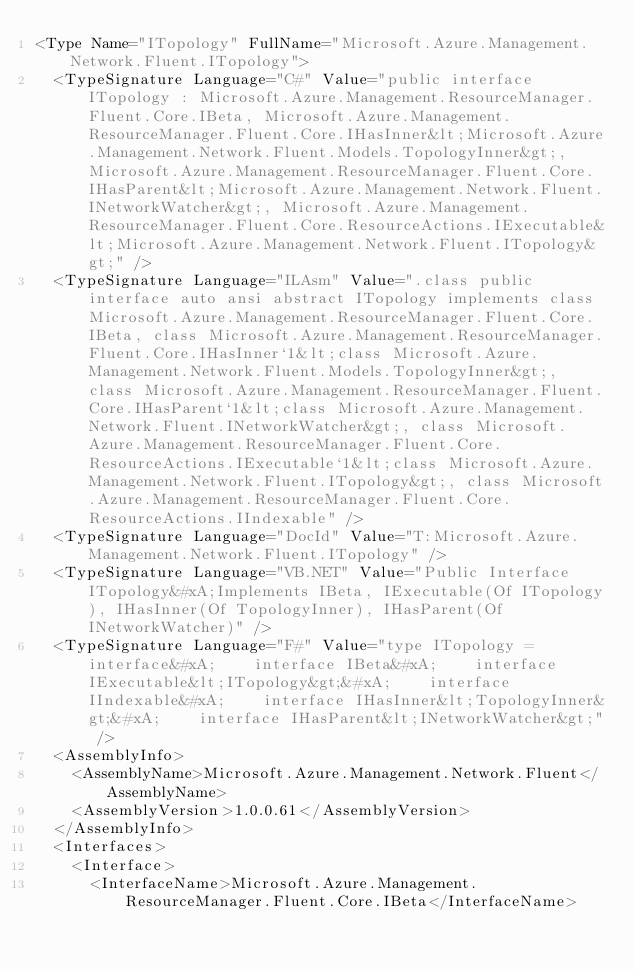<code> <loc_0><loc_0><loc_500><loc_500><_XML_><Type Name="ITopology" FullName="Microsoft.Azure.Management.Network.Fluent.ITopology">
  <TypeSignature Language="C#" Value="public interface ITopology : Microsoft.Azure.Management.ResourceManager.Fluent.Core.IBeta, Microsoft.Azure.Management.ResourceManager.Fluent.Core.IHasInner&lt;Microsoft.Azure.Management.Network.Fluent.Models.TopologyInner&gt;, Microsoft.Azure.Management.ResourceManager.Fluent.Core.IHasParent&lt;Microsoft.Azure.Management.Network.Fluent.INetworkWatcher&gt;, Microsoft.Azure.Management.ResourceManager.Fluent.Core.ResourceActions.IExecutable&lt;Microsoft.Azure.Management.Network.Fluent.ITopology&gt;" />
  <TypeSignature Language="ILAsm" Value=".class public interface auto ansi abstract ITopology implements class Microsoft.Azure.Management.ResourceManager.Fluent.Core.IBeta, class Microsoft.Azure.Management.ResourceManager.Fluent.Core.IHasInner`1&lt;class Microsoft.Azure.Management.Network.Fluent.Models.TopologyInner&gt;, class Microsoft.Azure.Management.ResourceManager.Fluent.Core.IHasParent`1&lt;class Microsoft.Azure.Management.Network.Fluent.INetworkWatcher&gt;, class Microsoft.Azure.Management.ResourceManager.Fluent.Core.ResourceActions.IExecutable`1&lt;class Microsoft.Azure.Management.Network.Fluent.ITopology&gt;, class Microsoft.Azure.Management.ResourceManager.Fluent.Core.ResourceActions.IIndexable" />
  <TypeSignature Language="DocId" Value="T:Microsoft.Azure.Management.Network.Fluent.ITopology" />
  <TypeSignature Language="VB.NET" Value="Public Interface ITopology&#xA;Implements IBeta, IExecutable(Of ITopology), IHasInner(Of TopologyInner), IHasParent(Of INetworkWatcher)" />
  <TypeSignature Language="F#" Value="type ITopology = interface&#xA;    interface IBeta&#xA;    interface IExecutable&lt;ITopology&gt;&#xA;    interface IIndexable&#xA;    interface IHasInner&lt;TopologyInner&gt;&#xA;    interface IHasParent&lt;INetworkWatcher&gt;" />
  <AssemblyInfo>
    <AssemblyName>Microsoft.Azure.Management.Network.Fluent</AssemblyName>
    <AssemblyVersion>1.0.0.61</AssemblyVersion>
  </AssemblyInfo>
  <Interfaces>
    <Interface>
      <InterfaceName>Microsoft.Azure.Management.ResourceManager.Fluent.Core.IBeta</InterfaceName></code> 